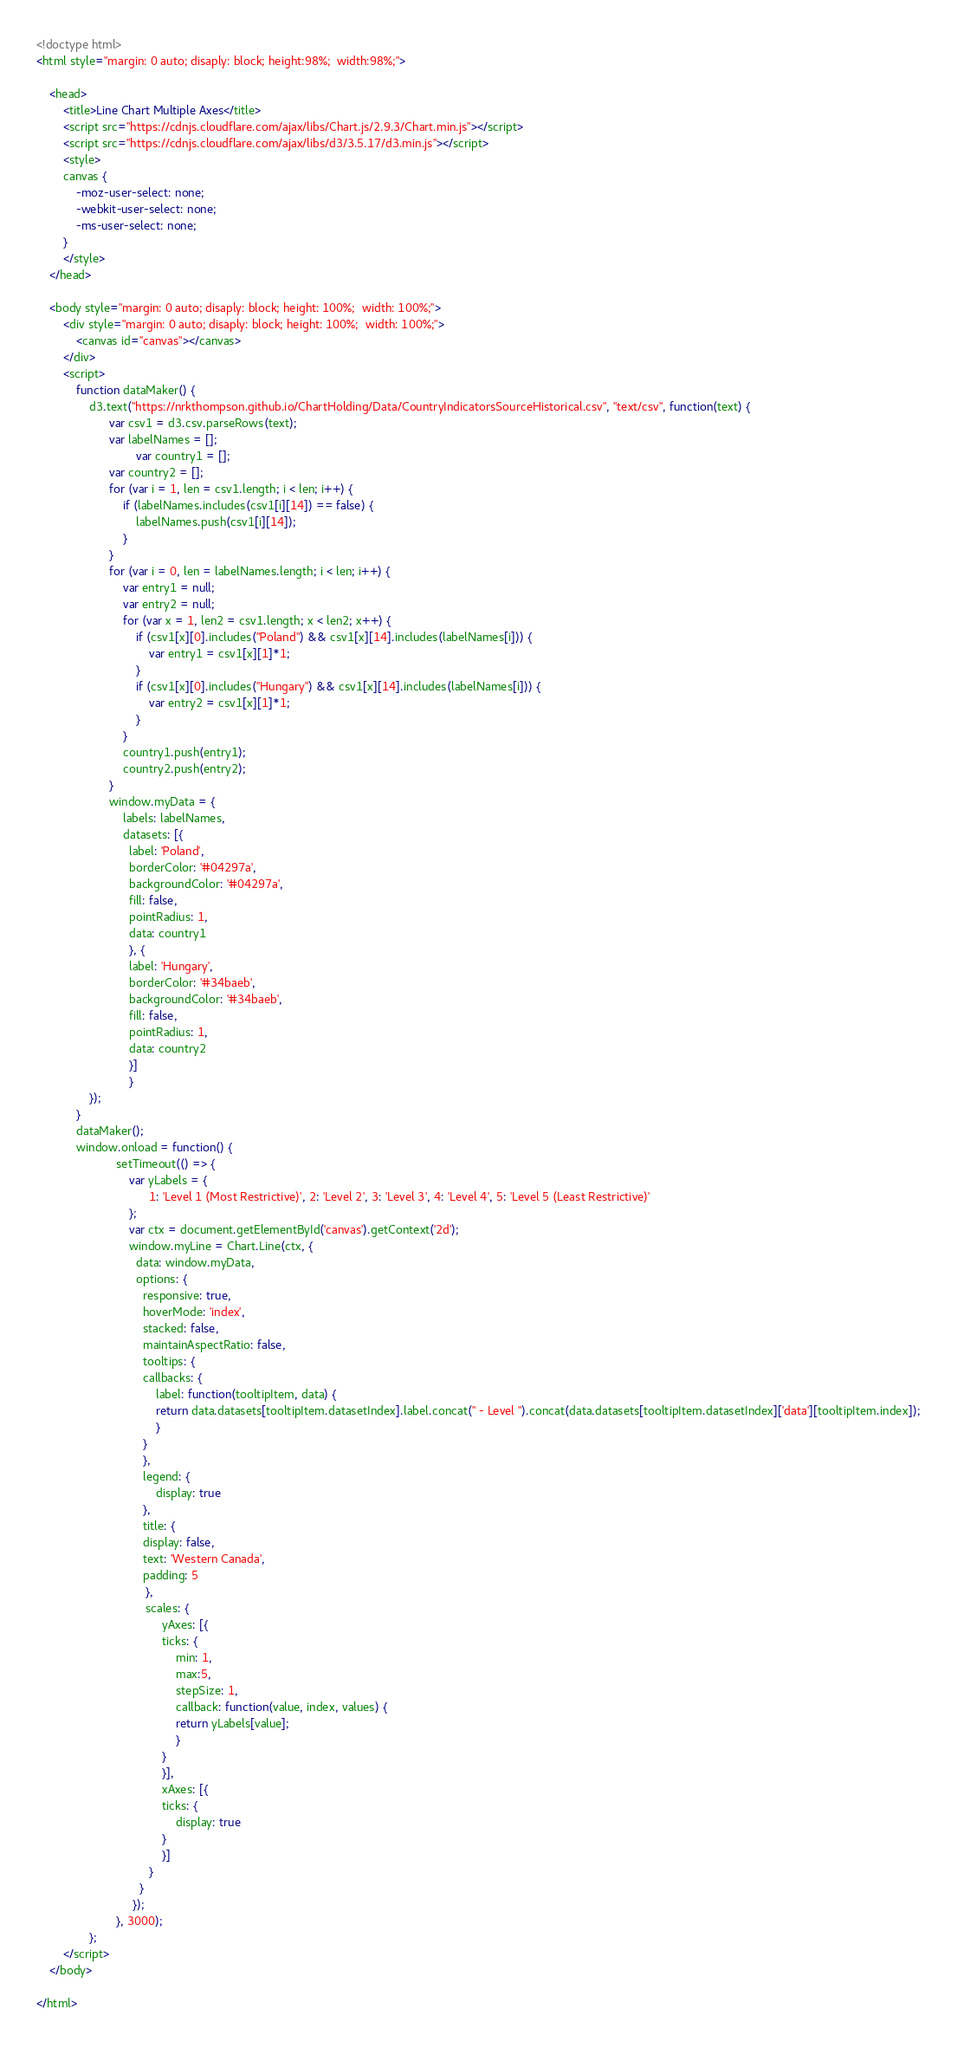<code> <loc_0><loc_0><loc_500><loc_500><_HTML_>
<!doctype html>
<html style="margin: 0 auto; disaply: block; height:98%;  width:98%;">

	<head>
		<title>Line Chart Multiple Axes</title>
		<script src="https://cdnjs.cloudflare.com/ajax/libs/Chart.js/2.9.3/Chart.min.js"></script>
		<script src="https://cdnjs.cloudflare.com/ajax/libs/d3/3.5.17/d3.min.js"></script>
		<style>
		canvas {
			-moz-user-select: none;
			-webkit-user-select: none;
			-ms-user-select: none;
		}
		</style>
	</head>

	<body style="margin: 0 auto; disaply: block; height: 100%;  width: 100%;">
		<div style="margin: 0 auto; disaply: block; height: 100%;  width: 100%;">
			<canvas id="canvas"></canvas>
		</div>
		<script>
			function dataMaker() {
				d3.text("https://nrkthompson.github.io/ChartHolding/Data/CountryIndicatorsSourceHistorical.csv", "text/csv", function(text) {
					  var csv1 = d3.csv.parseRows(text);
					  var labelNames = [];
            				  var country1 = [];
					  var country2 = [];
					  for (var i = 1, len = csv1.length; i < len; i++) {
						  if (labelNames.includes(csv1[i][14]) == false) {
							  labelNames.push(csv1[i][14]);
						  }
					  }
					  for (var i = 0, len = labelNames.length; i < len; i++) {
						  var entry1 = null;
						  var entry2 = null;
						  for (var x = 1, len2 = csv1.length; x < len2; x++) {
							  if (csv1[x][0].includes("Poland") && csv1[x][14].includes(labelNames[i])) {
								  var entry1 = csv1[x][1]*1;
							  }
							  if (csv1[x][0].includes("Hungary") && csv1[x][14].includes(labelNames[i])) {
								  var entry2 = csv1[x][1]*1;
							  }
						  }
						  country1.push(entry1);
						  country2.push(entry2);
					  }
					  window.myData = {
						  labels: labelNames,
						  datasets: [{
						    label: 'Poland',
						    borderColor: '#04297a',
						    backgroundColor: '#04297a',
						    fill: false,
						    pointRadius: 1,
						    data: country1
						    }, {
						    label: 'Hungary',
						    borderColor: '#34baeb',
						    backgroundColor: '#34baeb',
						    fill: false,
						    pointRadius: 1,
						    data: country2
						    }]
						    }  
				});
			}
			dataMaker();
			window.onload = function() {
						setTimeout(() => { 
							var yLabels = {
							      1: 'Level 1 (Most Restrictive)', 2: 'Level 2', 3: 'Level 3', 4: 'Level 4', 5: 'Level 5 (Least Restrictive)'
							};
							var ctx = document.getElementById('canvas').getContext('2d');
							window.myLine = Chart.Line(ctx, {
							  data: window.myData,
							  options: {
							    responsive: true,
							    hoverMode: 'index',
							    stacked: false,
							    maintainAspectRatio: false,
							    tooltips: {
								callbacks: {
								    label: function(tooltipItem, data) {
									return data.datasets[tooltipItem.datasetIndex].label.concat(" - Level ").concat(data.datasets[tooltipItem.datasetIndex]['data'][tooltipItem.index]);
								    }
								}
							    },
							    legend: {
								    display: true
							    },
							    title: {
								display: false,
								text: 'Western Canada',
								padding: 5
							     },
							     scales: {
								      yAxes: [{
									  ticks: {
									      min: 1,
									      max:5,
									      stepSize: 1,
									      callback: function(value, index, values) {
										  return yLabels[value];
									      }
									  }
								      }],
								      xAxes: [{
									  ticks: {
									      display: true
									  }
								      }]
								  }
							   }
							 });
						}, 3000);
				};
		</script>
	</body>

</html></code> 